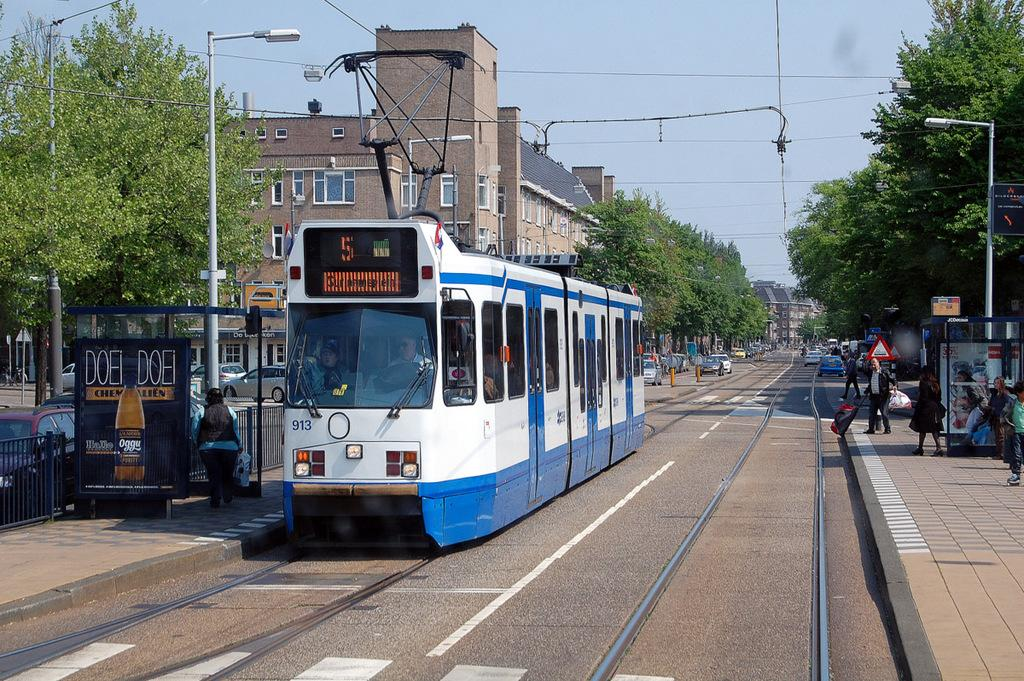What type of vehicle is present in the image? There is a tram in the image. Can you describe the people in the image? There are people in the image. What type of vegetation is visible in the image? There are trees in the image. What type of lighting is present in the image? There are street lights in the image. What type of structure is visible in the image? There are people in the image. What type of structure is visible in the image? There is a building in the image. What type of transportation is visible in the image? There are cars on the road in the image. What part of the natural environment is visible in the image? The sky is visible in the image. What type of smell can be detected coming from the group of people in the image? There is no indication of any smell in the image, and there is no group of people mentioned. 